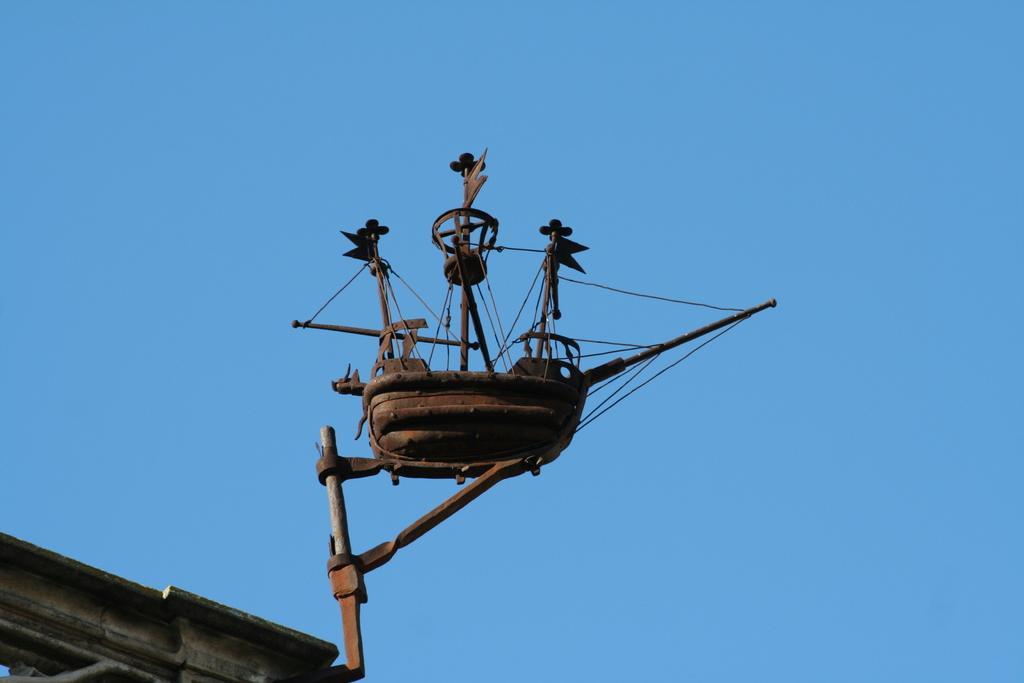Can you describe this image briefly? In this image I can see the metal object and the object is in brown color, background the sky is in blue color. 